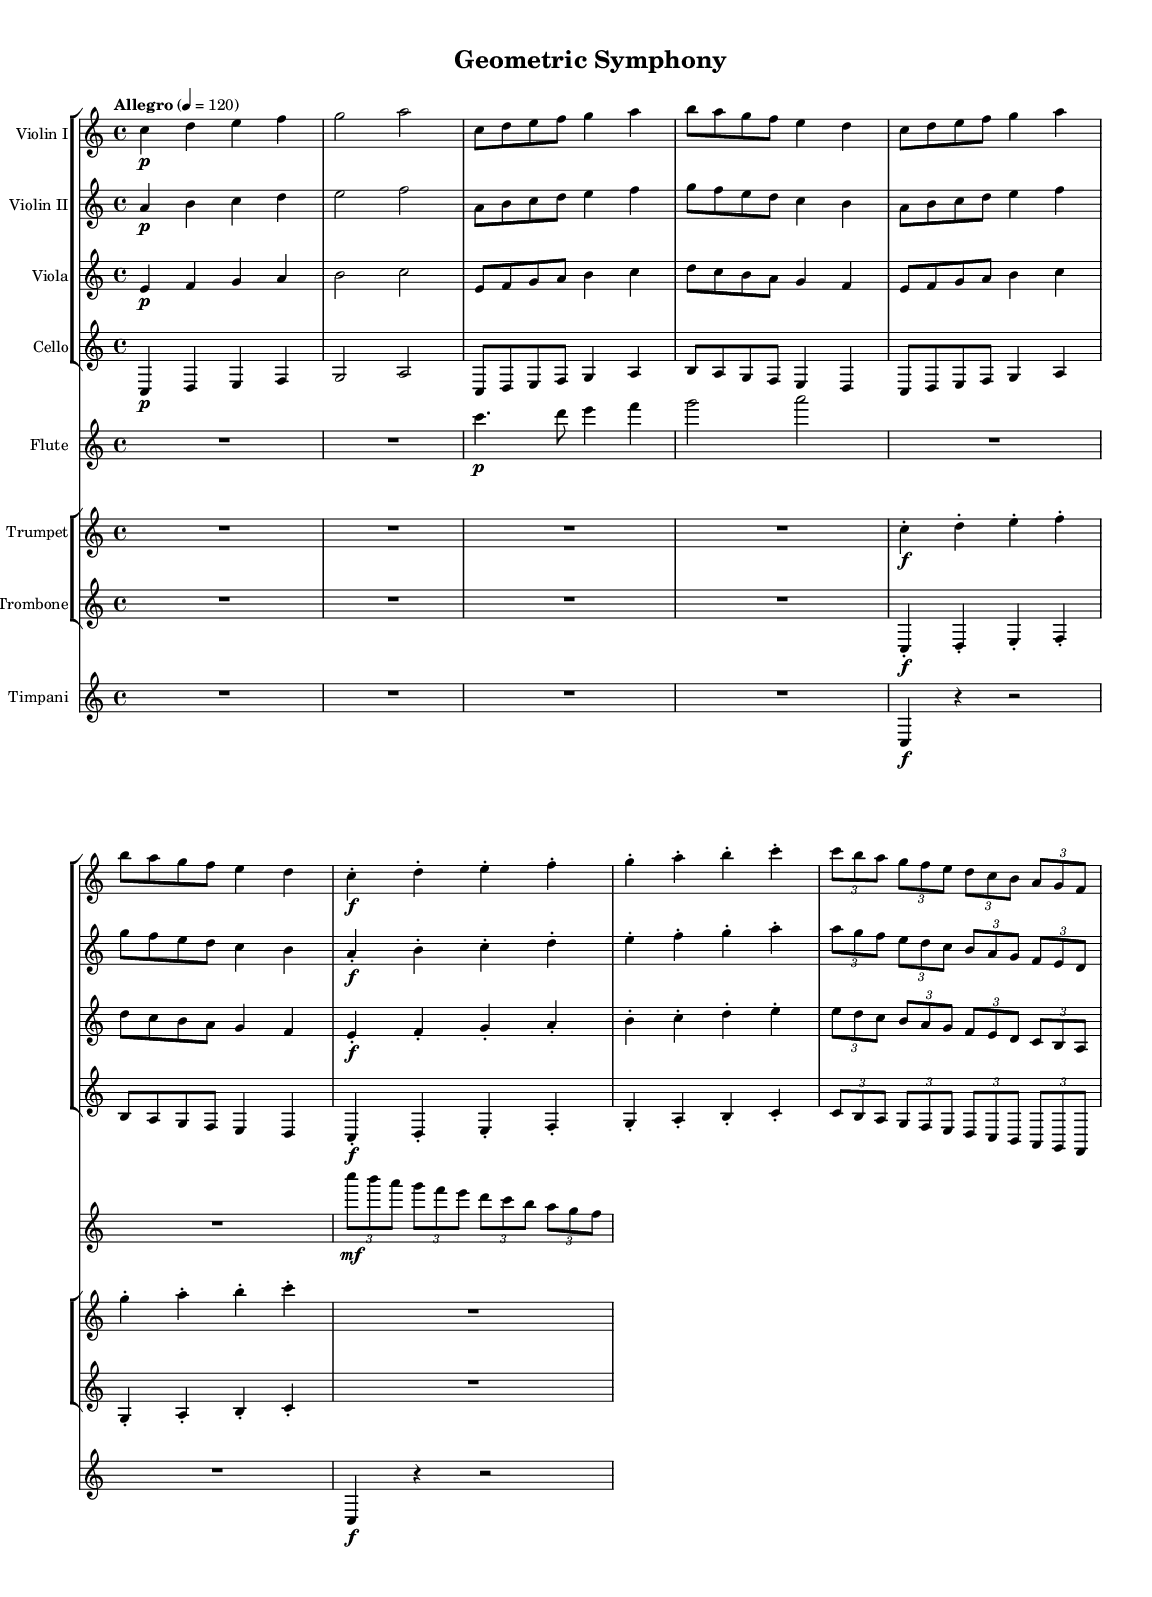What is the key signature of this music? The key signature is C major, which has no sharps or flats indicated in the score. The presence of natural notes without accidentals confirms this.
Answer: C major What is the time signature of this symphony? The time signature indicated at the beginning is 4/4, which means there are four beats in a measure and a quarter note gets one beat. This is noted at the start of the score.
Answer: 4/4 What is the tempo marking for this composition? The tempo marking is "Allegro," which directs the musicians to play in a lively and brisk manner. The specific beat rate of 120 is also noted.
Answer: Allegro How many themes are explored in this symphonic composition? There are three distinct themes labeled A, B, and C, each represented by different geometric shapes: Circle, Square, and Triangle, respectively.
Answer: 3 Which instruments play the introduction of the symphony? The introduction is played by the violin I, violin II, viola, and cello. The score shows these instruments beginning with the first measures of their respective staves.
Answer: Violin I, Violin II, Viola, Cello What unique rhythmic structure is used in Theme C for Violin I? Theme C uses a tuplet of 3 against 2, creating a polyrhythmic effect, which allows for a varied rhythm compared to the standard quarter notes. This is shown with the tuplet notation in the score.
Answer: Tuplet 3/2 Which geometric shape is represented by Theme A? Theme A is described as representing a Circle, based on the thematic title stated in the score. The melody in this section is written to capture the essence of circular motion.
Answer: Circle 